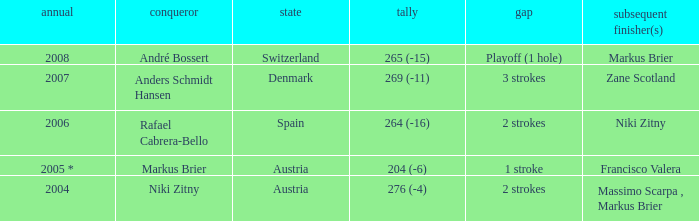Would you mind parsing the complete table? {'header': ['annual', 'conqueror', 'state', 'tally', 'gap', 'subsequent finisher(s)'], 'rows': [['2008', 'André Bossert', 'Switzerland', '265 (-15)', 'Playoff (1 hole)', 'Markus Brier'], ['2007', 'Anders Schmidt Hansen', 'Denmark', '269 (-11)', '3 strokes', 'Zane Scotland'], ['2006', 'Rafael Cabrera-Bello', 'Spain', '264 (-16)', '2 strokes', 'Niki Zitny'], ['2005 *', 'Markus Brier', 'Austria', '204 (-6)', '1 stroke', 'Francisco Valera'], ['2004', 'Niki Zitny', 'Austria', '276 (-4)', '2 strokes', 'Massimo Scarpa , Markus Brier']]} In what year was the score 204 (-6)? 2005 *. 